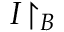Convert formula to latex. <formula><loc_0><loc_0><loc_500><loc_500>I { \upharpoonright _ { B } }</formula> 